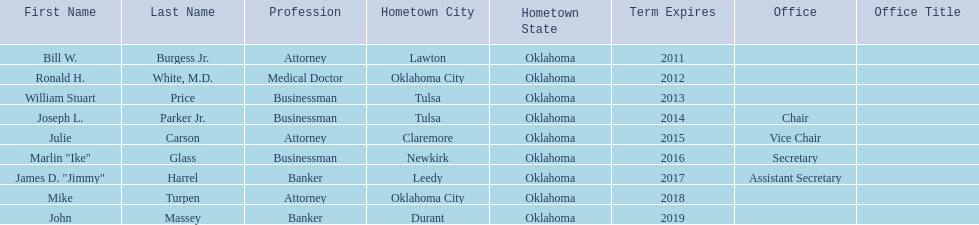Which regents are from tulsa? William Stuart Price, Joseph L. Parker Jr. Which of these is not joseph parker, jr.? William Stuart Price. Can you give me this table as a dict? {'header': ['First Name', 'Last Name', 'Profession', 'Hometown City', 'Hometown State', 'Term Expires', 'Office', 'Office Title'], 'rows': [['Bill W.', 'Burgess Jr.', 'Attorney', 'Lawton', 'Oklahoma', '2011', '', ''], ['Ronald H.', 'White, M.D.', 'Medical Doctor', 'Oklahoma City', 'Oklahoma', '2012', '', ''], ['William Stuart', 'Price', 'Businessman', 'Tulsa', 'Oklahoma', '2013', '', ''], ['Joseph L.', 'Parker Jr.', 'Businessman', 'Tulsa', 'Oklahoma', '2014', 'Chair', ''], ['Julie', 'Carson', 'Attorney', 'Claremore', 'Oklahoma', '2015', 'Vice Chair', ''], ['Marlin "Ike"', 'Glass', 'Businessman', 'Newkirk', 'Oklahoma', '2016', 'Secretary', ''], ['James D. "Jimmy"', 'Harrel', 'Banker', 'Leedy', 'Oklahoma', '2017', 'Assistant Secretary', ''], ['Mike', 'Turpen', 'Attorney', 'Oklahoma City', 'Oklahoma', '2018', '', ''], ['John', 'Massey', 'Banker', 'Durant', 'Oklahoma', '2019', '', '']]} 